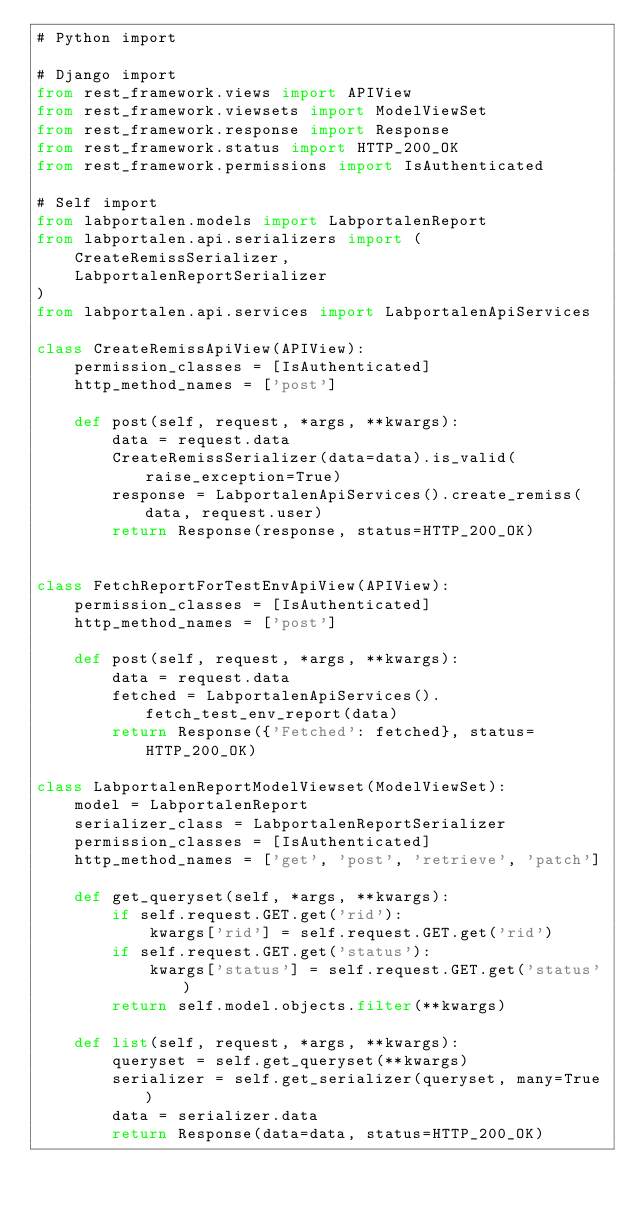<code> <loc_0><loc_0><loc_500><loc_500><_Python_># Python import

# Django import
from rest_framework.views import APIView
from rest_framework.viewsets import ModelViewSet
from rest_framework.response import Response
from rest_framework.status import HTTP_200_OK
from rest_framework.permissions import IsAuthenticated

# Self import
from labportalen.models import LabportalenReport
from labportalen.api.serializers import (
    CreateRemissSerializer,
    LabportalenReportSerializer
)
from labportalen.api.services import LabportalenApiServices

class CreateRemissApiView(APIView):
    permission_classes = [IsAuthenticated]
    http_method_names = ['post']

    def post(self, request, *args, **kwargs):
        data = request.data
        CreateRemissSerializer(data=data).is_valid(raise_exception=True)
        response = LabportalenApiServices().create_remiss(data, request.user)
        return Response(response, status=HTTP_200_OK)
    

class FetchReportForTestEnvApiView(APIView):
    permission_classes = [IsAuthenticated]
    http_method_names = ['post']

    def post(self, request, *args, **kwargs):
        data = request.data
        fetched = LabportalenApiServices().fetch_test_env_report(data)
        return Response({'Fetched': fetched}, status=HTTP_200_OK)

class LabportalenReportModelViewset(ModelViewSet):
    model = LabportalenReport
    serializer_class = LabportalenReportSerializer
    permission_classes = [IsAuthenticated]
    http_method_names = ['get', 'post', 'retrieve', 'patch']

    def get_queryset(self, *args, **kwargs):
        if self.request.GET.get('rid'):
            kwargs['rid'] = self.request.GET.get('rid')
        if self.request.GET.get('status'):
            kwargs['status'] = self.request.GET.get('status')
        return self.model.objects.filter(**kwargs)

    def list(self, request, *args, **kwargs):
        queryset = self.get_queryset(**kwargs)
        serializer = self.get_serializer(queryset, many=True)
        data = serializer.data
        return Response(data=data, status=HTTP_200_OK)</code> 